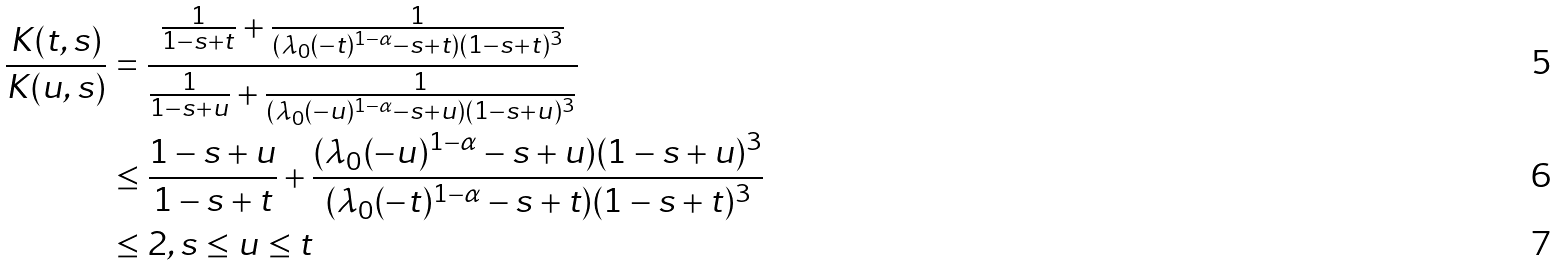<formula> <loc_0><loc_0><loc_500><loc_500>\frac { K ( t , s ) } { K ( u , s ) } & = \frac { \frac { 1 } { 1 - s + t } + \frac { 1 } { ( \lambda _ { 0 } ( - t ) ^ { 1 - \alpha } - s + t ) ( 1 - s + t ) ^ { 3 } } } { \frac { 1 } { 1 - s + u } + \frac { 1 } { ( \lambda _ { 0 } ( - u ) ^ { 1 - \alpha } - s + u ) ( 1 - s + u ) ^ { 3 } } } \\ & \leq \frac { 1 - s + u } { 1 - s + t } + \frac { ( \lambda _ { 0 } ( - u ) ^ { 1 - \alpha } - s + u ) ( 1 - s + u ) ^ { 3 } } { ( \lambda _ { 0 } ( - t ) ^ { 1 - \alpha } - s + t ) ( 1 - s + t ) ^ { 3 } } \\ & \leq 2 , s \leq u \leq t</formula> 